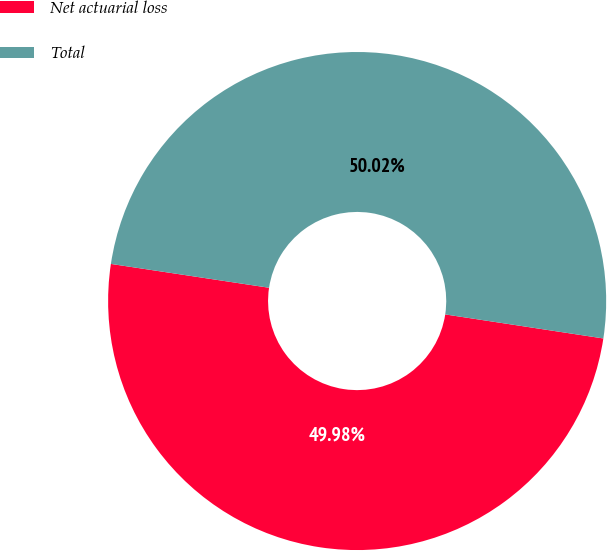Convert chart. <chart><loc_0><loc_0><loc_500><loc_500><pie_chart><fcel>Net actuarial loss<fcel>Total<nl><fcel>49.98%<fcel>50.02%<nl></chart> 